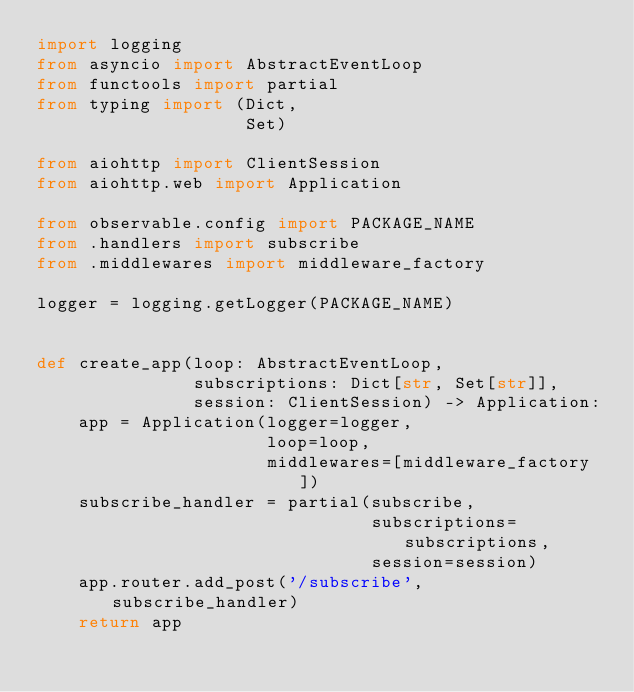Convert code to text. <code><loc_0><loc_0><loc_500><loc_500><_Python_>import logging
from asyncio import AbstractEventLoop
from functools import partial
from typing import (Dict,
                    Set)

from aiohttp import ClientSession
from aiohttp.web import Application

from observable.config import PACKAGE_NAME
from .handlers import subscribe
from .middlewares import middleware_factory

logger = logging.getLogger(PACKAGE_NAME)


def create_app(loop: AbstractEventLoop,
               subscriptions: Dict[str, Set[str]],
               session: ClientSession) -> Application:
    app = Application(logger=logger,
                      loop=loop,
                      middlewares=[middleware_factory])
    subscribe_handler = partial(subscribe,
                                subscriptions=subscriptions,
                                session=session)
    app.router.add_post('/subscribe', subscribe_handler)
    return app
</code> 